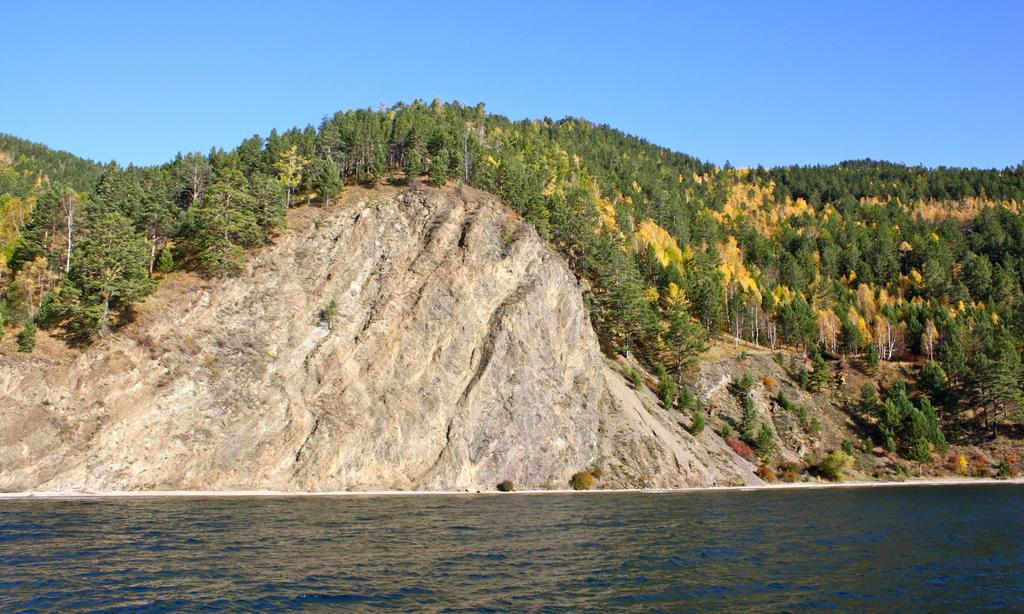What is the main feature of the landscape in the image? There is a river flowing in the image. What can be seen on the opposite side of the river? On the other side of the river, there are mountains and trees. What type of pan can be seen hanging from the tree on the other side of the river? There is no pan present in the image; only the river, mountains, and trees are visible. 